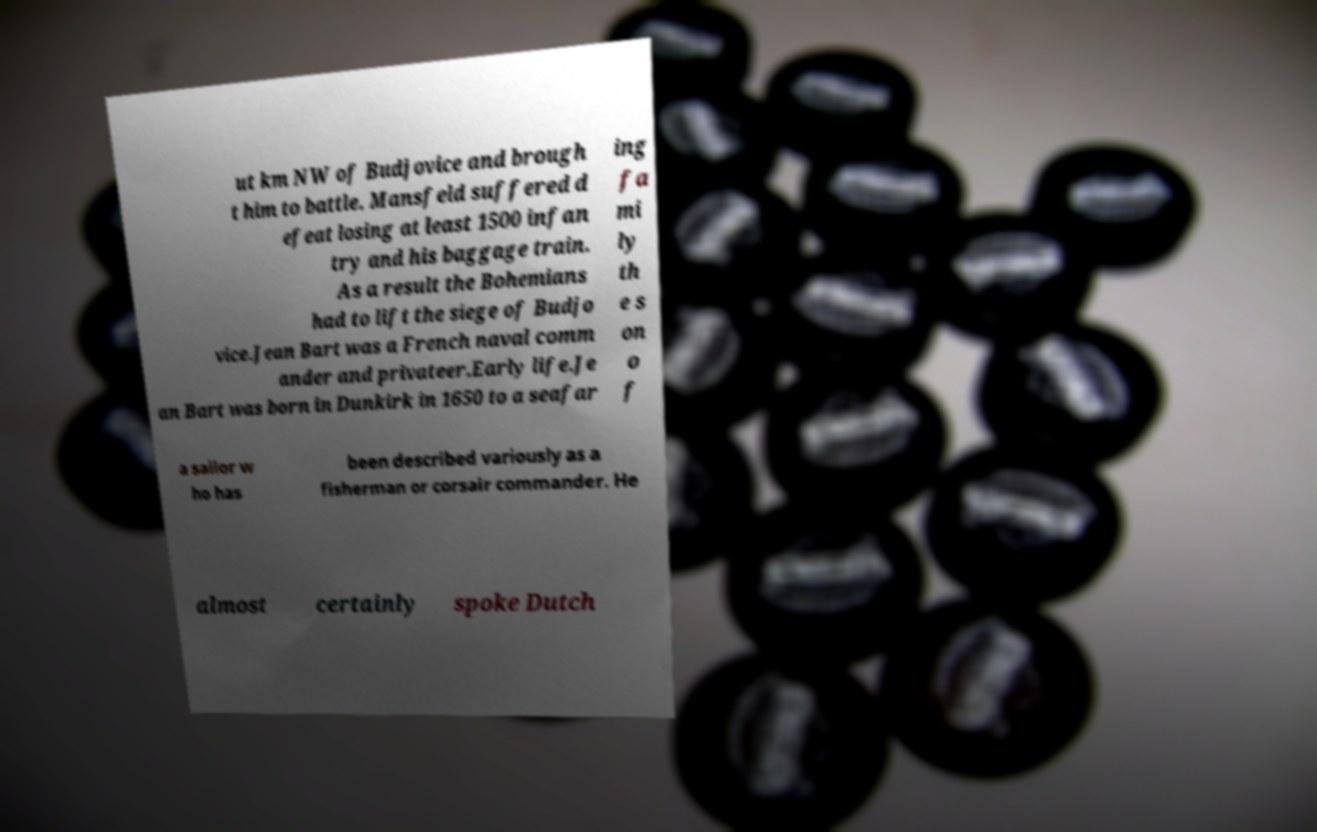Could you assist in decoding the text presented in this image and type it out clearly? ut km NW of Budjovice and brough t him to battle. Mansfeld suffered d efeat losing at least 1500 infan try and his baggage train. As a result the Bohemians had to lift the siege of Budjo vice.Jean Bart was a French naval comm ander and privateer.Early life.Je an Bart was born in Dunkirk in 1650 to a seafar ing fa mi ly th e s on o f a sailor w ho has been described variously as a fisherman or corsair commander. He almost certainly spoke Dutch 